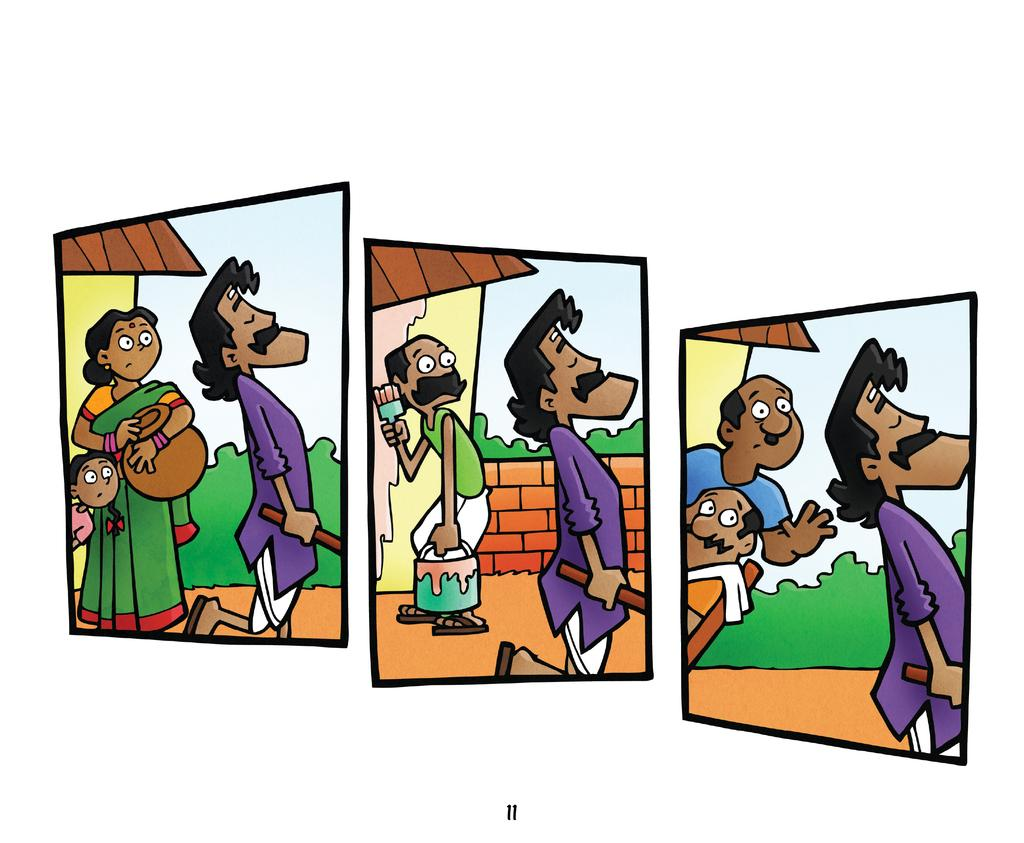What type of characters are present in the image? There are cartoon characters in the image. What is the aftermath of the throat infection in the image? There is no mention of a throat infection in the image, as it only features cartoon characters. 